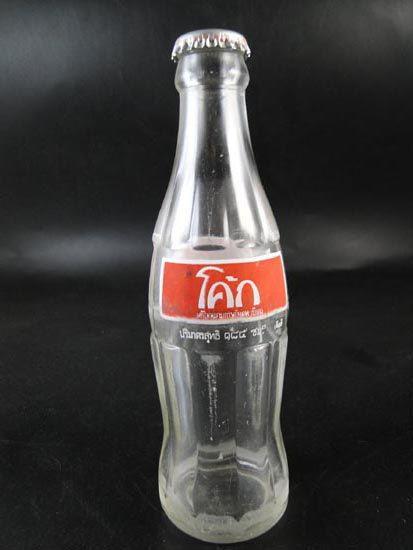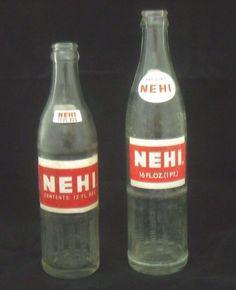The first image is the image on the left, the second image is the image on the right. For the images shown, is this caption "At least 5 bottles are standing side by side in one of the pictures." true? Answer yes or no. No. The first image is the image on the left, the second image is the image on the right. Examine the images to the left and right. Is the description "There are more than three bottles." accurate? Answer yes or no. No. 